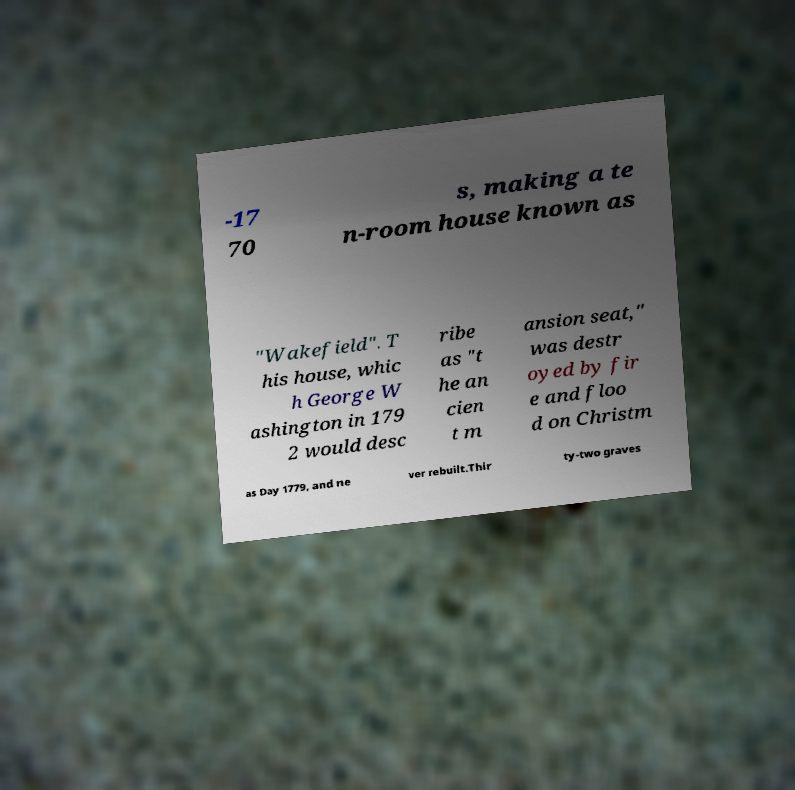What messages or text are displayed in this image? I need them in a readable, typed format. -17 70 s, making a te n-room house known as "Wakefield". T his house, whic h George W ashington in 179 2 would desc ribe as "t he an cien t m ansion seat," was destr oyed by fir e and floo d on Christm as Day 1779, and ne ver rebuilt.Thir ty-two graves 